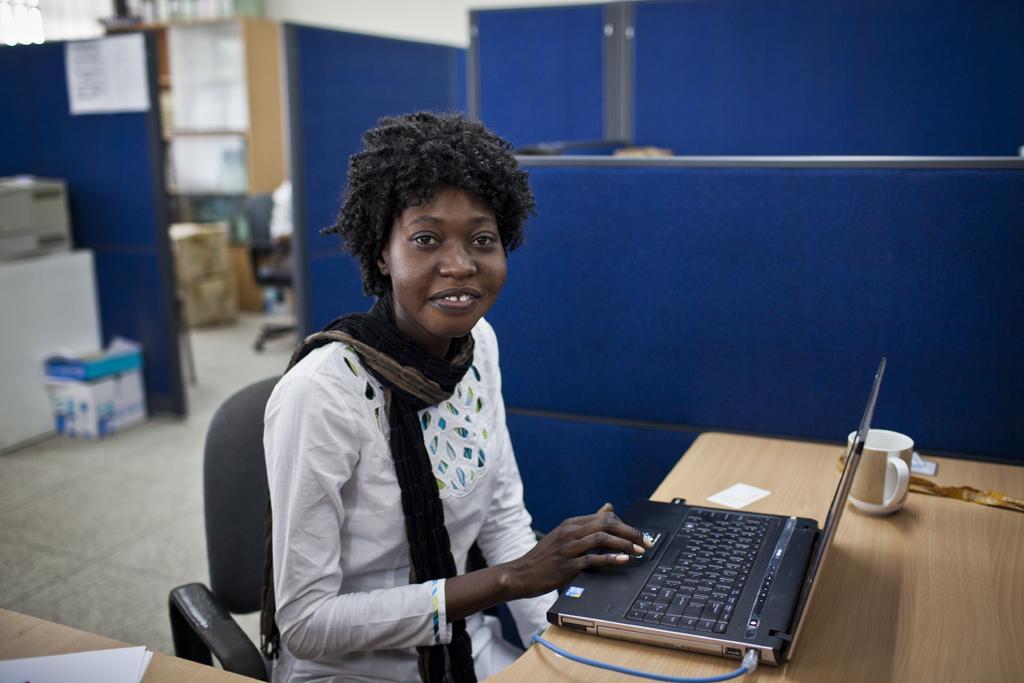Can you describe this image briefly? In this picture we can see a laptop cup on the table, in front of the table we can see a woman seated on the chair, in the background we can see boxes and cupboards. 